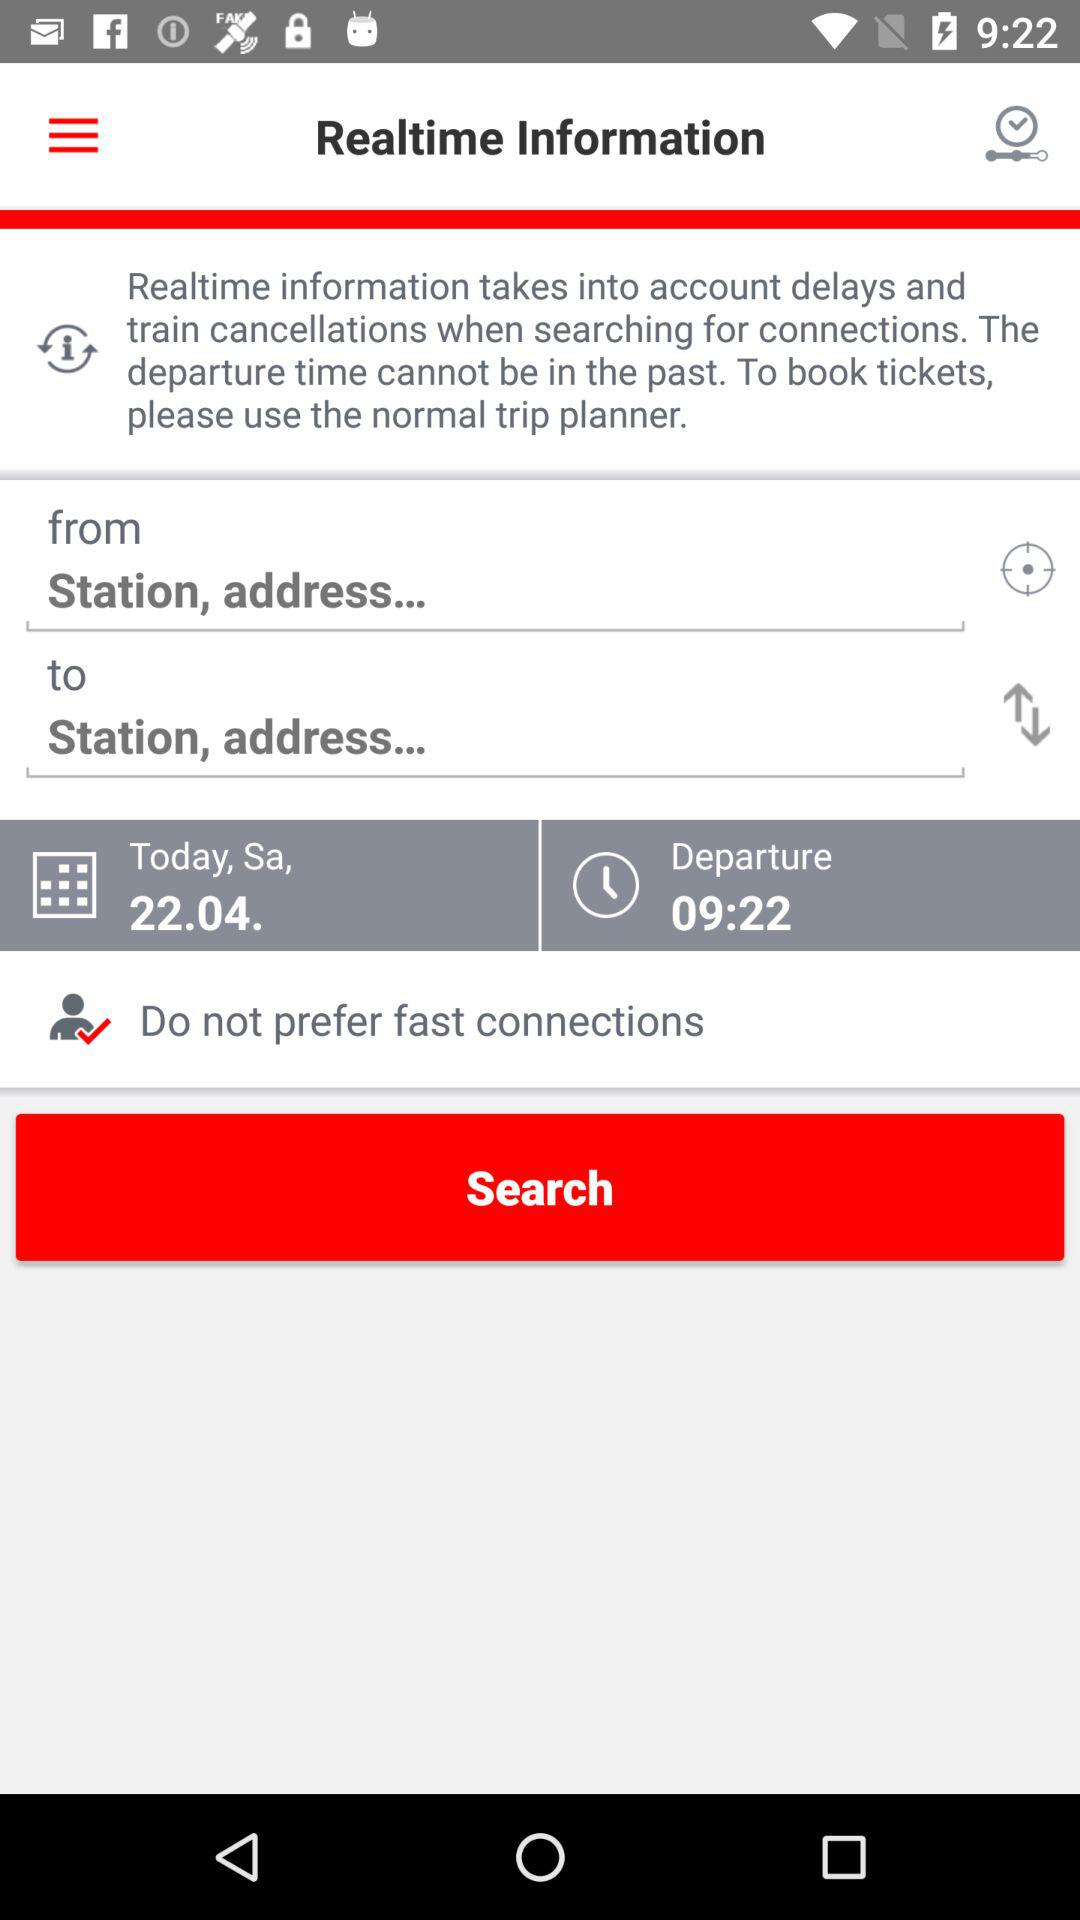What is the application name? The application name is "trip planner". 